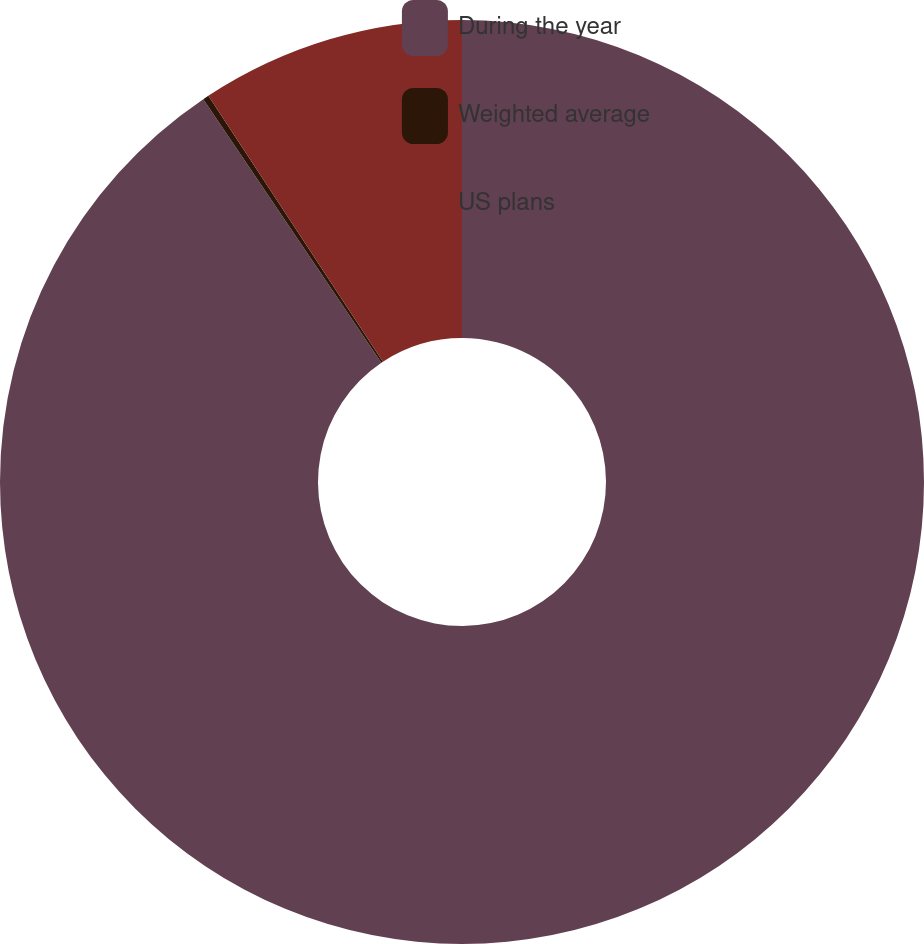Convert chart. <chart><loc_0><loc_0><loc_500><loc_500><pie_chart><fcel>During the year<fcel>Weighted average<fcel>US plans<nl><fcel>90.54%<fcel>0.21%<fcel>9.25%<nl></chart> 